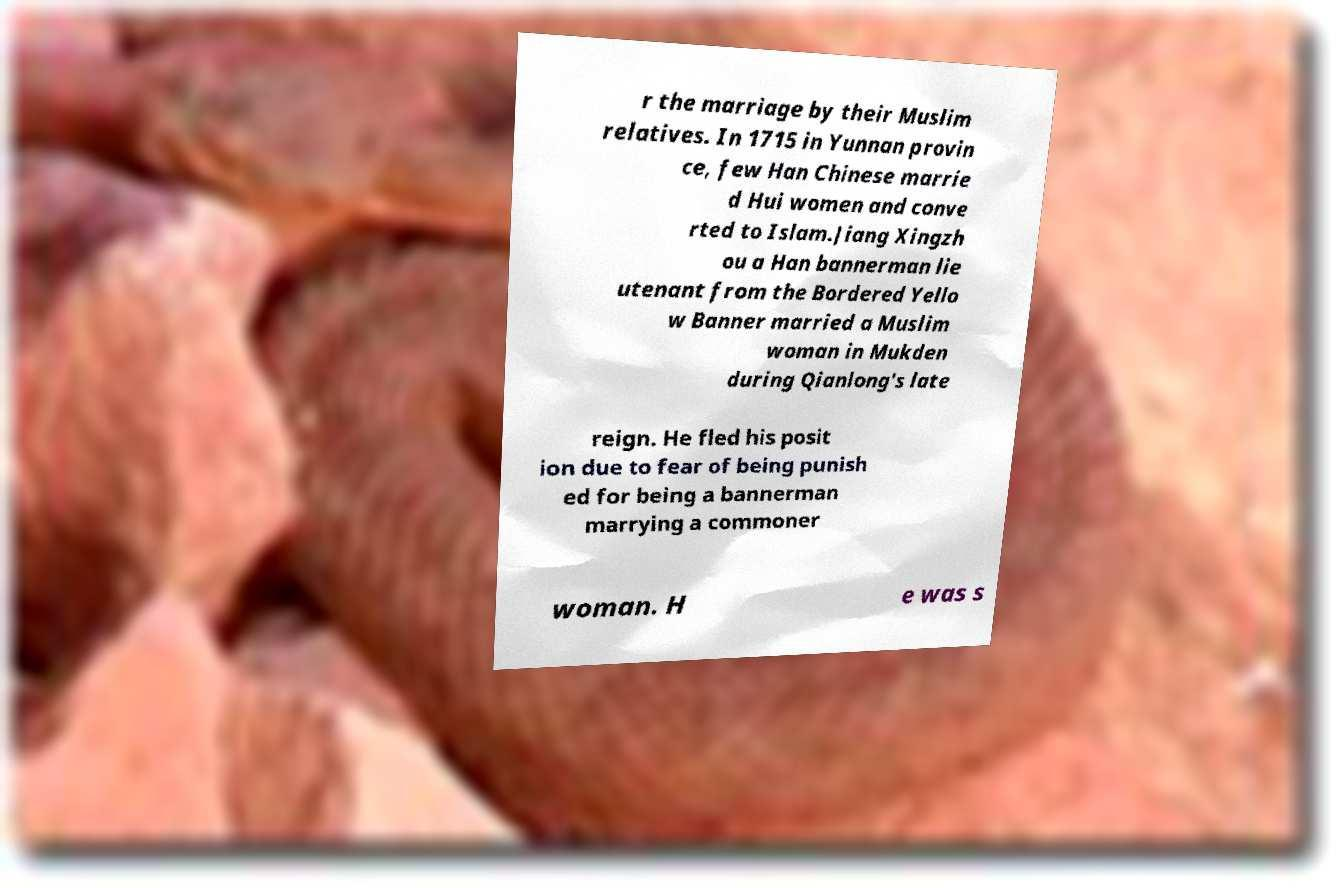There's text embedded in this image that I need extracted. Can you transcribe it verbatim? r the marriage by their Muslim relatives. In 1715 in Yunnan provin ce, few Han Chinese marrie d Hui women and conve rted to Islam.Jiang Xingzh ou a Han bannerman lie utenant from the Bordered Yello w Banner married a Muslim woman in Mukden during Qianlong's late reign. He fled his posit ion due to fear of being punish ed for being a bannerman marrying a commoner woman. H e was s 